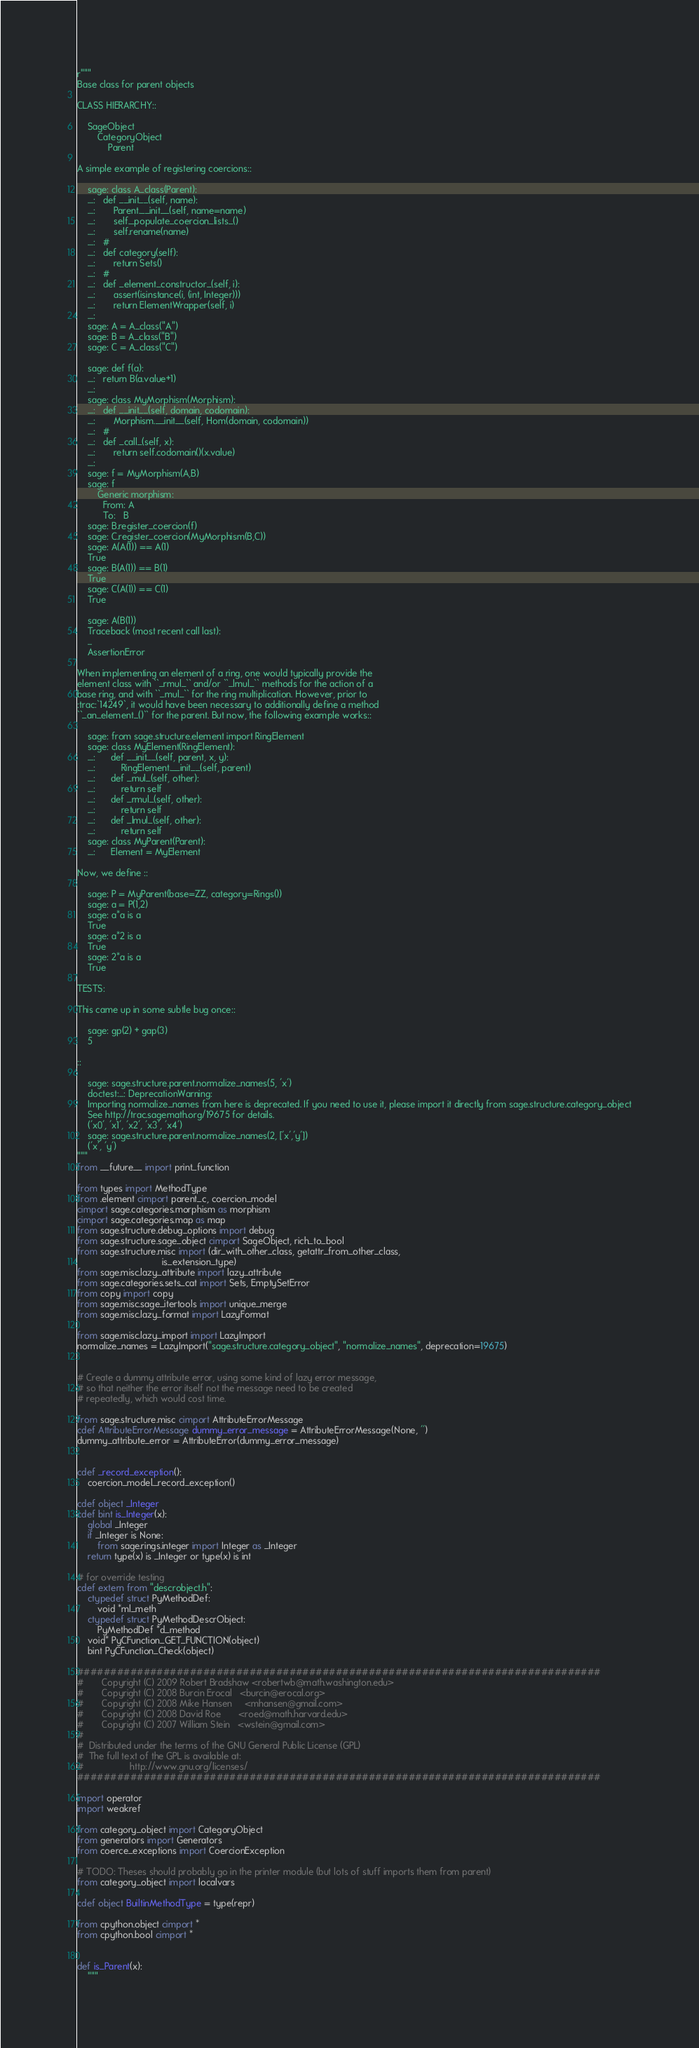<code> <loc_0><loc_0><loc_500><loc_500><_Cython_>r"""
Base class for parent objects

CLASS HIERARCHY::

    SageObject
        CategoryObject
            Parent

A simple example of registering coercions::

    sage: class A_class(Parent):
    ....:   def __init__(self, name):
    ....:       Parent.__init__(self, name=name)
    ....:       self._populate_coercion_lists_()
    ....:       self.rename(name)
    ....:   #
    ....:   def category(self):
    ....:       return Sets()
    ....:   #
    ....:   def _element_constructor_(self, i):
    ....:       assert(isinstance(i, (int, Integer)))
    ....:       return ElementWrapper(self, i)
    ....:
    sage: A = A_class("A")
    sage: B = A_class("B")
    sage: C = A_class("C")

    sage: def f(a):
    ....:   return B(a.value+1)
    ....:
    sage: class MyMorphism(Morphism):
    ....:   def __init__(self, domain, codomain):
    ....:       Morphism.__init__(self, Hom(domain, codomain))
    ....:   #
    ....:   def _call_(self, x):
    ....:       return self.codomain()(x.value)
    ....:
    sage: f = MyMorphism(A,B)
    sage: f
        Generic morphism:
          From: A
          To:   B
    sage: B.register_coercion(f)
    sage: C.register_coercion(MyMorphism(B,C))
    sage: A(A(1)) == A(1)
    True
    sage: B(A(1)) == B(1)
    True
    sage: C(A(1)) == C(1)
    True

    sage: A(B(1))
    Traceback (most recent call last):
    ...
    AssertionError

When implementing an element of a ring, one would typically provide the
element class with ``_rmul_`` and/or ``_lmul_`` methods for the action of a
base ring, and with ``_mul_`` for the ring multiplication. However, prior to
:trac:`14249`, it would have been necessary to additionally define a method
``_an_element_()`` for the parent. But now, the following example works::

    sage: from sage.structure.element import RingElement
    sage: class MyElement(RingElement):
    ....:      def __init__(self, parent, x, y):
    ....:          RingElement.__init__(self, parent)
    ....:      def _mul_(self, other):
    ....:          return self
    ....:      def _rmul_(self, other):
    ....:          return self
    ....:      def _lmul_(self, other):
    ....:          return self
    sage: class MyParent(Parent):
    ....:      Element = MyElement

Now, we define ::

    sage: P = MyParent(base=ZZ, category=Rings())
    sage: a = P(1,2)
    sage: a*a is a
    True
    sage: a*2 is a
    True
    sage: 2*a is a
    True

TESTS:

This came up in some subtle bug once::

    sage: gp(2) + gap(3)
    5

::

    sage: sage.structure.parent.normalize_names(5, 'x')
    doctest:...: DeprecationWarning:
    Importing normalize_names from here is deprecated. If you need to use it, please import it directly from sage.structure.category_object
    See http://trac.sagemath.org/19675 for details.
    ('x0', 'x1', 'x2', 'x3', 'x4')
    sage: sage.structure.parent.normalize_names(2, ['x','y'])
    ('x', 'y')
"""
from __future__ import print_function

from types import MethodType
from .element cimport parent_c, coercion_model
cimport sage.categories.morphism as morphism
cimport sage.categories.map as map
from sage.structure.debug_options import debug
from sage.structure.sage_object cimport SageObject, rich_to_bool
from sage.structure.misc import (dir_with_other_class, getattr_from_other_class,
                                 is_extension_type)
from sage.misc.lazy_attribute import lazy_attribute
from sage.categories.sets_cat import Sets, EmptySetError
from copy import copy
from sage.misc.sage_itertools import unique_merge
from sage.misc.lazy_format import LazyFormat

from sage.misc.lazy_import import LazyImport
normalize_names = LazyImport("sage.structure.category_object", "normalize_names", deprecation=19675)


# Create a dummy attribute error, using some kind of lazy error message,
# so that neither the error itself not the message need to be created
# repeatedly, which would cost time.

from sage.structure.misc cimport AttributeErrorMessage
cdef AttributeErrorMessage dummy_error_message = AttributeErrorMessage(None, '')
dummy_attribute_error = AttributeError(dummy_error_message)


cdef _record_exception():
    coercion_model._record_exception()

cdef object _Integer
cdef bint is_Integer(x):
    global _Integer
    if _Integer is None:
        from sage.rings.integer import Integer as _Integer
    return type(x) is _Integer or type(x) is int

# for override testing
cdef extern from "descrobject.h":
    ctypedef struct PyMethodDef:
        void *ml_meth
    ctypedef struct PyMethodDescrObject:
        PyMethodDef *d_method
    void* PyCFunction_GET_FUNCTION(object)
    bint PyCFunction_Check(object)

###############################################################################
#       Copyright (C) 2009 Robert Bradshaw <robertwb@math.washington.edu>
#       Copyright (C) 2008 Burcin Erocal   <burcin@erocal.org>
#       Copyright (C) 2008 Mike Hansen     <mhansen@gmail.com>
#       Copyright (C) 2008 David Roe       <roed@math.harvard.edu>
#       Copyright (C) 2007 William Stein   <wstein@gmail.com>
#
#  Distributed under the terms of the GNU General Public License (GPL)
#  The full text of the GPL is available at:
#                  http://www.gnu.org/licenses/
###############################################################################

import operator
import weakref

from category_object import CategoryObject
from generators import Generators
from coerce_exceptions import CoercionException

# TODO: Theses should probably go in the printer module (but lots of stuff imports them from parent)
from category_object import localvars

cdef object BuiltinMethodType = type(repr)

from cpython.object cimport *
from cpython.bool cimport *


def is_Parent(x):
    """</code> 